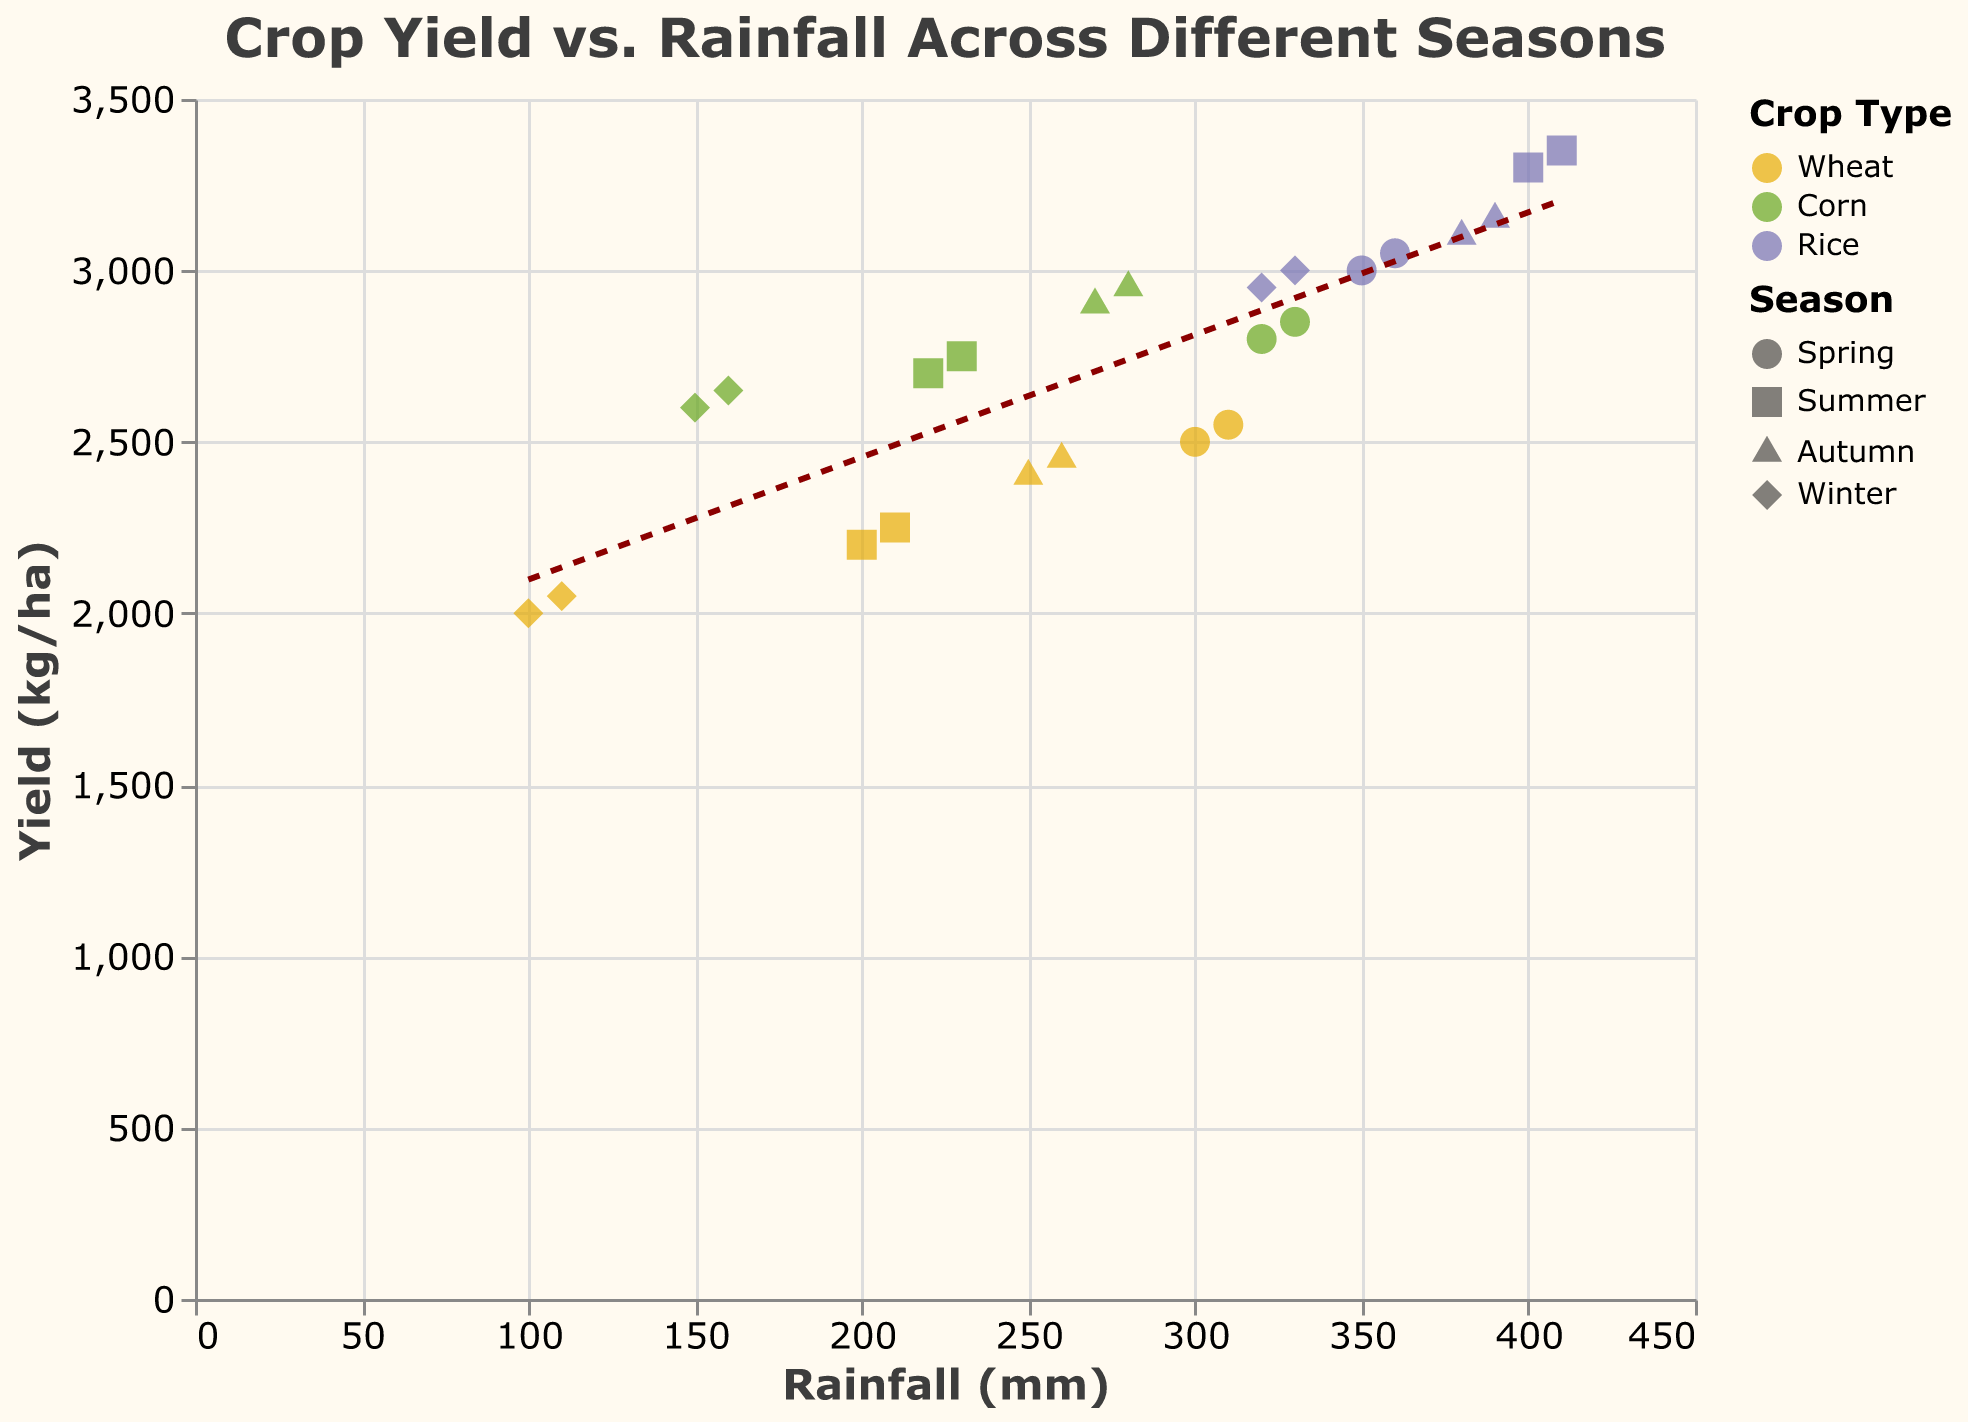what is the title of the plot? The title is prominently displayed at the top of the plot. It reads "Crop Yield vs. Rainfall Across Different Seasons."
Answer: Crop Yield vs. Rainfall Across Different Seasons Which crop shows the highest yield in the plot? By observing the scatter plot, we can see that the points representing Rice have the highest yield values.
Answer: Rice What shape represents data from the Summer season? The legend of the plot indicates that data from the Summer season is represented by square shapes.
Answer: Square How does rainfall affect crop yield according to the trend line? The trend line indicates a positive relationship between rainfall and crop yield, meaning that as rainfall increases, the crop yield tends to increase as well.
Answer: Yield increases with rainfall What is the general trend for Wheat yield with increasing rainfall? Examining the points and the trend line associated with Wheat shows that the yield generally increases as rainfall increases.
Answer: Increases Compare the yields of Wheat and Corn in the Winter season. Which has higher values? Observing the points in the Winter season (diamond shapes) for Wheat and Corn, Corn tends to have higher yield values than Wheat.
Answer: Corn Which season seems to have the lowest recorded rainfall? By looking at the x-axis and identifying the points with the lowest rainfall, the Winter season (diamond shapes) has the lowest recorded rainfall.
Answer: Winter What is the relationship between Rainfall (mm) and Yield (kg/ha) for Rice in the Spring season? Spring season is represented by circles, and observing the Rice points, we see that higher rainfall corresponds to higher yield for Rice in the Spring.
Answer: Positive relationship What's the color used to visualize Wheat in the plot? According to the legend, Wheat is represented by the color yellow (#E6AB02).
Answer: Yellow Identify the crop with the lowest yield in Summer. Observing the data points for Summer (square shapes), Wheat has the lowest yield in the Summer season.
Answer: Wheat 